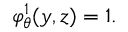<formula> <loc_0><loc_0><loc_500><loc_500>\varphi _ { \theta } ^ { 1 } ( y , z ) = 1 .</formula> 